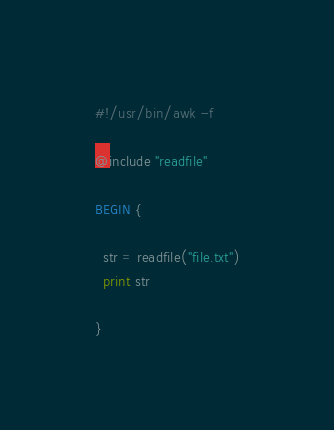Convert code to text. <code><loc_0><loc_0><loc_500><loc_500><_Awk_>#!/usr/bin/awk -f

@include "readfile"

BEGIN {

  str = readfile("file.txt")
  print str

}
</code> 